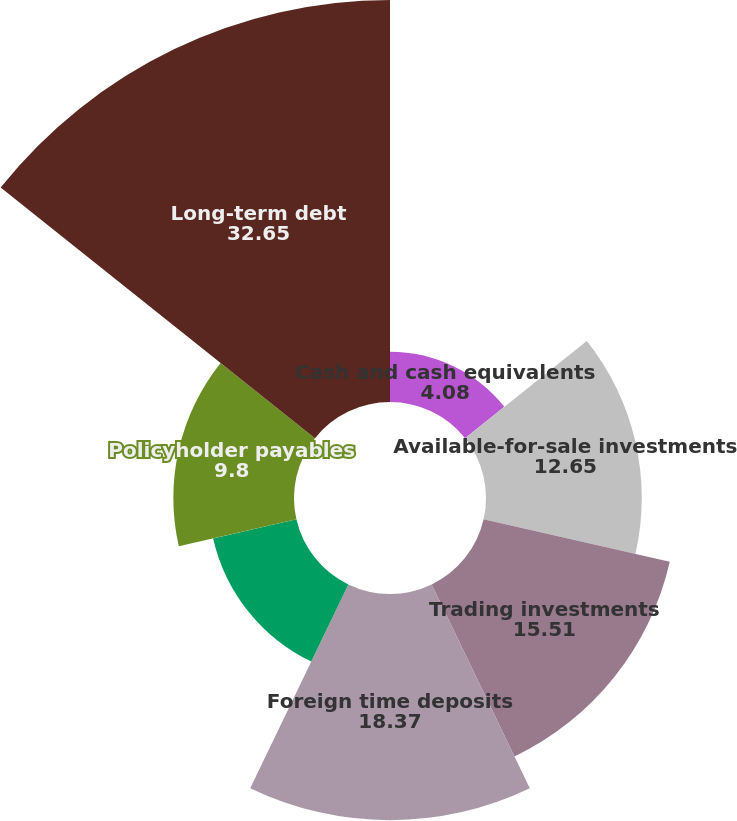<chart> <loc_0><loc_0><loc_500><loc_500><pie_chart><fcel>Cash and cash equivalents<fcel>Available-for-sale investments<fcel>Trading investments<fcel>Foreign time deposits<fcel>Assets held for policyholders<fcel>Policyholder payables<fcel>Long-term debt<nl><fcel>4.08%<fcel>12.65%<fcel>15.51%<fcel>18.37%<fcel>6.94%<fcel>9.8%<fcel>32.65%<nl></chart> 